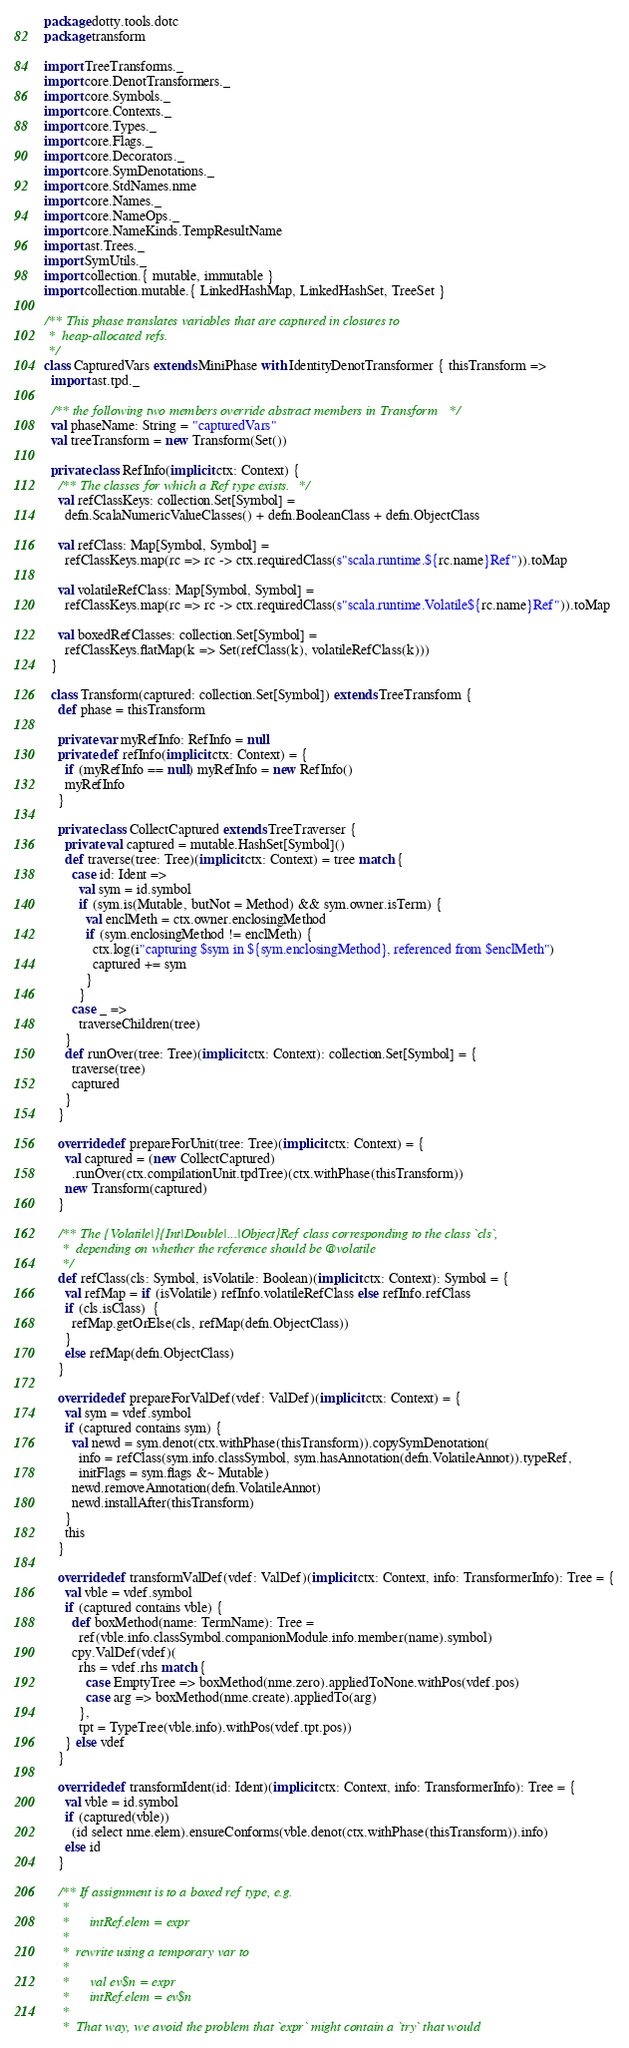<code> <loc_0><loc_0><loc_500><loc_500><_Scala_>package dotty.tools.dotc
package transform

import TreeTransforms._
import core.DenotTransformers._
import core.Symbols._
import core.Contexts._
import core.Types._
import core.Flags._
import core.Decorators._
import core.SymDenotations._
import core.StdNames.nme
import core.Names._
import core.NameOps._
import core.NameKinds.TempResultName
import ast.Trees._
import SymUtils._
import collection.{ mutable, immutable }
import collection.mutable.{ LinkedHashMap, LinkedHashSet, TreeSet }

/** This phase translates variables that are captured in closures to
 *  heap-allocated refs.
 */
class CapturedVars extends MiniPhase with IdentityDenotTransformer { thisTransform =>
  import ast.tpd._

  /** the following two members override abstract members in Transform */
  val phaseName: String = "capturedVars"
  val treeTransform = new Transform(Set())

  private class RefInfo(implicit ctx: Context) {
    /** The classes for which a Ref type exists. */
    val refClassKeys: collection.Set[Symbol] =
      defn.ScalaNumericValueClasses() + defn.BooleanClass + defn.ObjectClass

    val refClass: Map[Symbol, Symbol] =
      refClassKeys.map(rc => rc -> ctx.requiredClass(s"scala.runtime.${rc.name}Ref")).toMap

    val volatileRefClass: Map[Symbol, Symbol] =
      refClassKeys.map(rc => rc -> ctx.requiredClass(s"scala.runtime.Volatile${rc.name}Ref")).toMap

    val boxedRefClasses: collection.Set[Symbol] =
      refClassKeys.flatMap(k => Set(refClass(k), volatileRefClass(k)))
  }

  class Transform(captured: collection.Set[Symbol]) extends TreeTransform {
    def phase = thisTransform

    private var myRefInfo: RefInfo = null
    private def refInfo(implicit ctx: Context) = {
      if (myRefInfo == null) myRefInfo = new RefInfo()
      myRefInfo
    }

    private class CollectCaptured extends TreeTraverser {
      private val captured = mutable.HashSet[Symbol]()
      def traverse(tree: Tree)(implicit ctx: Context) = tree match {
        case id: Ident =>
          val sym = id.symbol
          if (sym.is(Mutable, butNot = Method) && sym.owner.isTerm) {
            val enclMeth = ctx.owner.enclosingMethod
            if (sym.enclosingMethod != enclMeth) {
              ctx.log(i"capturing $sym in ${sym.enclosingMethod}, referenced from $enclMeth")
              captured += sym
            }
          }
        case _ =>
          traverseChildren(tree)
      }
      def runOver(tree: Tree)(implicit ctx: Context): collection.Set[Symbol] = {
        traverse(tree)
        captured
      }
    }

    override def prepareForUnit(tree: Tree)(implicit ctx: Context) = {
      val captured = (new CollectCaptured)
        .runOver(ctx.compilationUnit.tpdTree)(ctx.withPhase(thisTransform))
      new Transform(captured)
    }

    /** The {Volatile|}{Int|Double|...|Object}Ref class corresponding to the class `cls`,
     *  depending on whether the reference should be @volatile
     */
    def refClass(cls: Symbol, isVolatile: Boolean)(implicit ctx: Context): Symbol = {
      val refMap = if (isVolatile) refInfo.volatileRefClass else refInfo.refClass
      if (cls.isClass)  {
        refMap.getOrElse(cls, refMap(defn.ObjectClass))
      }
      else refMap(defn.ObjectClass)
    }

    override def prepareForValDef(vdef: ValDef)(implicit ctx: Context) = {
      val sym = vdef.symbol
      if (captured contains sym) {
        val newd = sym.denot(ctx.withPhase(thisTransform)).copySymDenotation(
          info = refClass(sym.info.classSymbol, sym.hasAnnotation(defn.VolatileAnnot)).typeRef,
          initFlags = sym.flags &~ Mutable)
        newd.removeAnnotation(defn.VolatileAnnot)
        newd.installAfter(thisTransform)
      }
      this
    }

    override def transformValDef(vdef: ValDef)(implicit ctx: Context, info: TransformerInfo): Tree = {
      val vble = vdef.symbol
      if (captured contains vble) {
        def boxMethod(name: TermName): Tree =
          ref(vble.info.classSymbol.companionModule.info.member(name).symbol)
        cpy.ValDef(vdef)(
          rhs = vdef.rhs match {
            case EmptyTree => boxMethod(nme.zero).appliedToNone.withPos(vdef.pos)
            case arg => boxMethod(nme.create).appliedTo(arg)
          },
          tpt = TypeTree(vble.info).withPos(vdef.tpt.pos))
      } else vdef
    }

    override def transformIdent(id: Ident)(implicit ctx: Context, info: TransformerInfo): Tree = {
      val vble = id.symbol
      if (captured(vble))
        (id select nme.elem).ensureConforms(vble.denot(ctx.withPhase(thisTransform)).info)
      else id
    }

    /** If assignment is to a boxed ref type, e.g.
     *
     *      intRef.elem = expr
     *
     *  rewrite using a temporary var to
     *
     *      val ev$n = expr
     *      intRef.elem = ev$n
     *
     *  That way, we avoid the problem that `expr` might contain a `try` that would</code> 